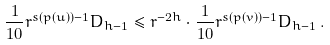<formula> <loc_0><loc_0><loc_500><loc_500>\frac { 1 } { 1 0 } r ^ { s ( p ( u ) ) - 1 } D _ { h - 1 } \leq r ^ { - 2 h } \cdot \frac { 1 } { 1 0 } r ^ { s ( p ( v ) ) - 1 } D _ { h - 1 } \, .</formula> 